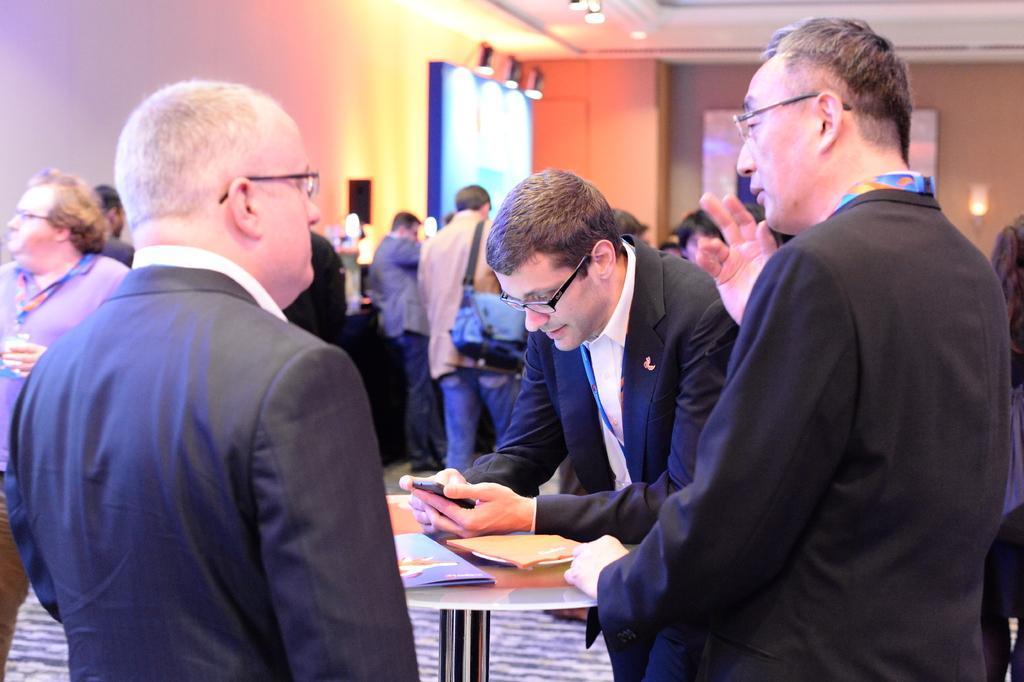Can you describe this image briefly? In this picture we can see a group of people wore blazer, spectacle carrying their bags and standing and in front of them there is table and on table we can see books and in background we can see wall, light. 